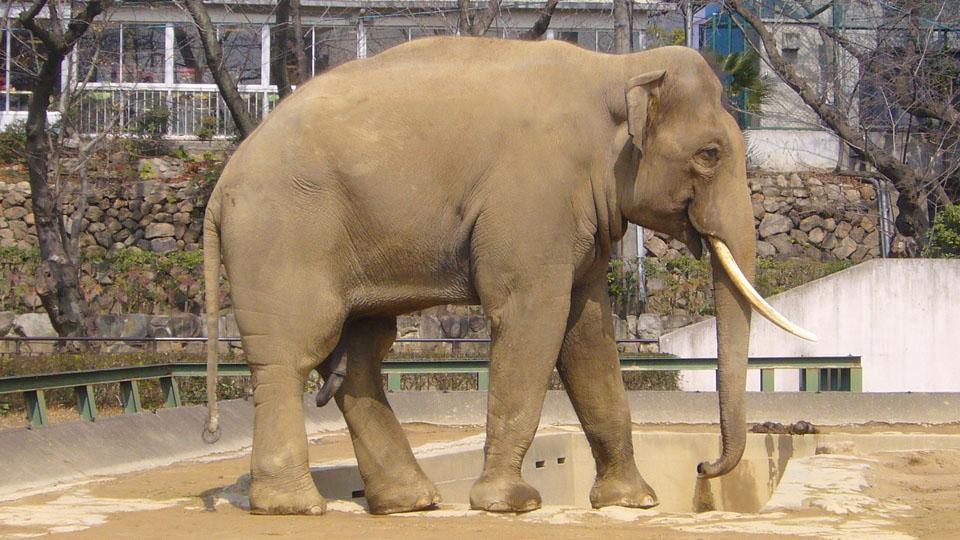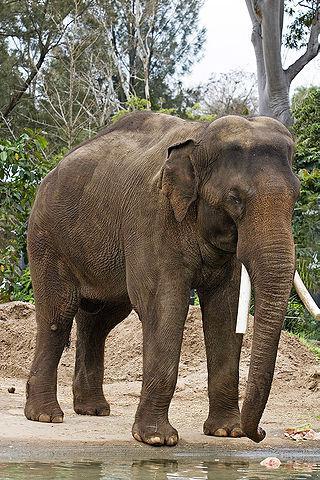The first image is the image on the left, the second image is the image on the right. Evaluate the accuracy of this statement regarding the images: "Each image shows a single elephant, and all elephants have tusks.". Is it true? Answer yes or no. Yes. The first image is the image on the left, the second image is the image on the right. Evaluate the accuracy of this statement regarding the images: "At least one of the elephants does not have tusks.". Is it true? Answer yes or no. No. 